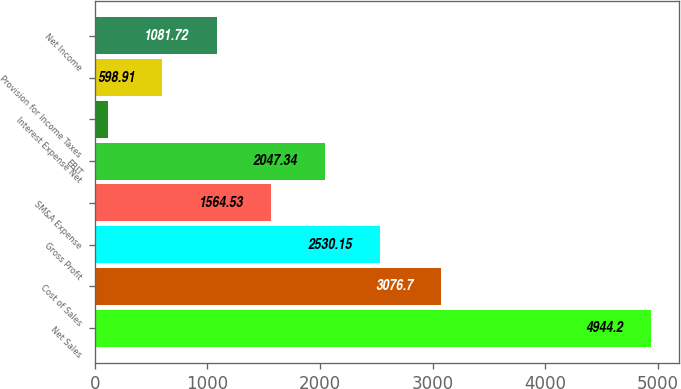Convert chart to OTSL. <chart><loc_0><loc_0><loc_500><loc_500><bar_chart><fcel>Net Sales<fcel>Cost of Sales<fcel>Gross Profit<fcel>SM&A Expense<fcel>EBIT<fcel>Interest Expense Net<fcel>Provision for Income Taxes<fcel>Net Income<nl><fcel>4944.2<fcel>3076.7<fcel>2530.15<fcel>1564.53<fcel>2047.34<fcel>116.1<fcel>598.91<fcel>1081.72<nl></chart> 